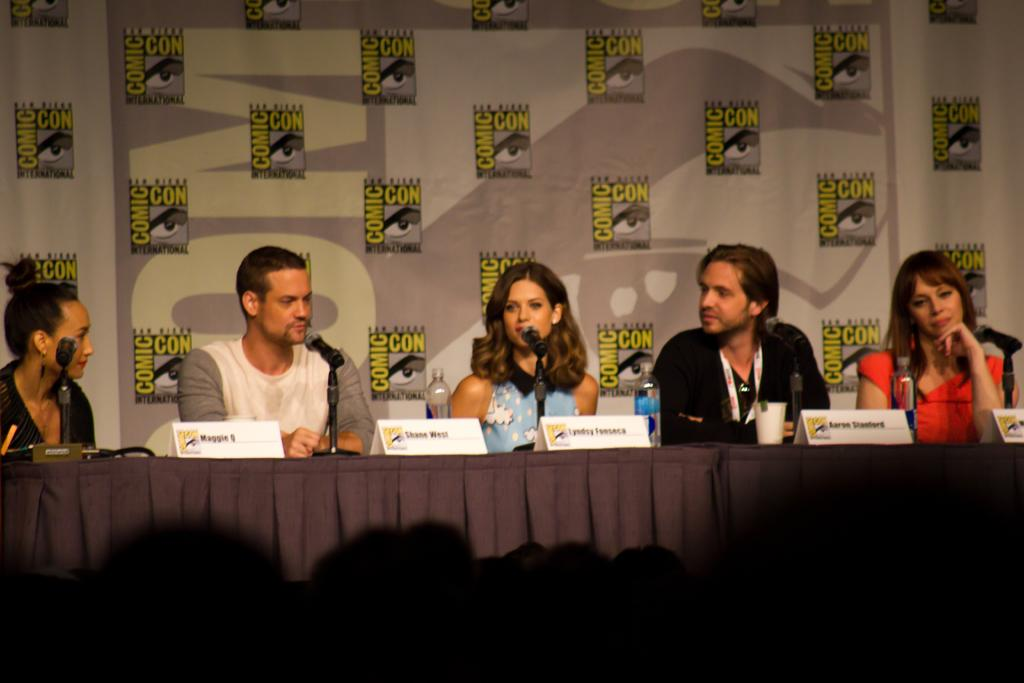How many people are in the image? There is a group of people in the image. What are the people doing in the image? The people are seated on chairs and speaking using microphones. What can be seen in the background of the image? There is a hoarding visible in the image. What color is the rose on the chair in the image? There is no rose present in the image. 